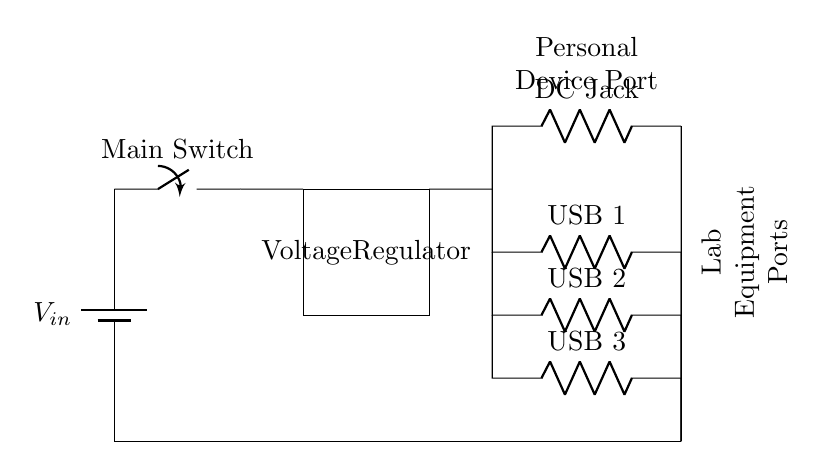What type of power supply is used in this circuit? The circuit uses a battery power supply, indicated by the symbol for a battery and labeled as \(V_{in}\).
Answer: Battery What are the output types provided by the charging station? The circuit has three USB ports and one DC jack as output connections for personal devices and lab equipment.
Answer: USB ports and DC jack What is the function of the voltage regulator in this circuit? The voltage regulator is used to maintain a constant voltage output for the devices connected, ensuring they receive the appropriate voltage regardless of battery discharge levels.
Answer: Maintain voltage How many USB ports are available for connection? The circuit diagram shows three USB ports labeled as USB 1, USB 2, and USB 3, allowing for multiple device connections.
Answer: Three What is the role of the main switch in the circuit? The main switch controls the flow of electricity from the battery to the rest of the circuit, allowing for safe operation and connection/disconnection of power.
Answer: Controls power flow Which component is used for the connection of personal devices? The DC jack serves as a dedicated output for connecting personal devices, as labeled in the diagram.
Answer: DC jack 